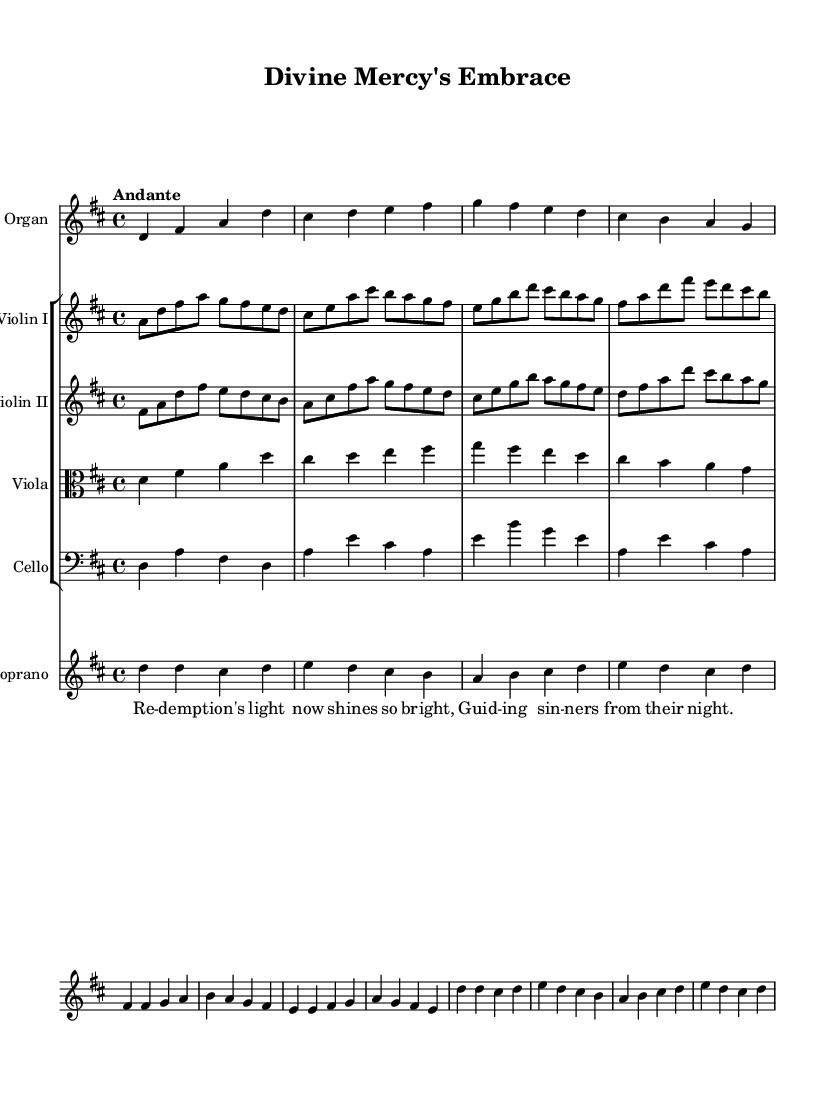What is the key signature of this music? The key signature indicated at the beginning of the score is D major, which has two sharps (F# and C#).
Answer: D major What is the time signature of this music? The time signature found in the score is 4/4, meaning there are four beats in each measure.
Answer: 4/4 What is the tempo marking of the piece? The score indicates the tempo marking as "Andante," suggesting a moderately slow tempo.
Answer: Andante How many different instruments are featured in this piece? By counting the number of different staff lines, there are five distinct instruments represented: Organ, Violin I, Violin II, Viola, and Cello.
Answer: Five How many beats are in the first measure of the organ music? Looking at the first measure of the organ music, there are four quarter notes (d, fis, a, d), which adds up to four beats.
Answer: Four What is the main theme expressed in the soprano lyrics? The soprano lyrics focus on the theme of redemption and the guiding light that helps sinners find their way. Specifically, the words mention redemption's light shining bright to guide sinners.
Answer: Redemption Which instruments have the same music in this piece? The Organ and Viola have identical music lines; both contain the same notes throughout the piece.
Answer: Organ and Viola 